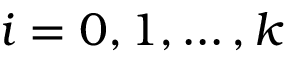Convert formula to latex. <formula><loc_0><loc_0><loc_500><loc_500>i = 0 , 1 , \dots , k</formula> 